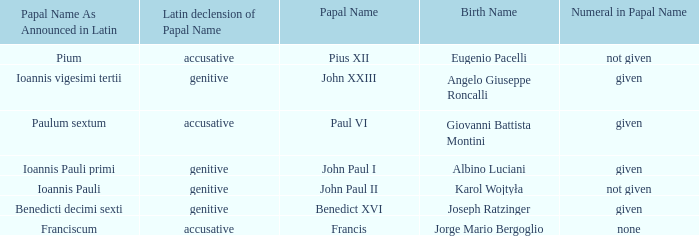For the pope born Eugenio Pacelli, what is the declension of his papal name? Accusative. 